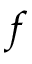<formula> <loc_0><loc_0><loc_500><loc_500>f</formula> 